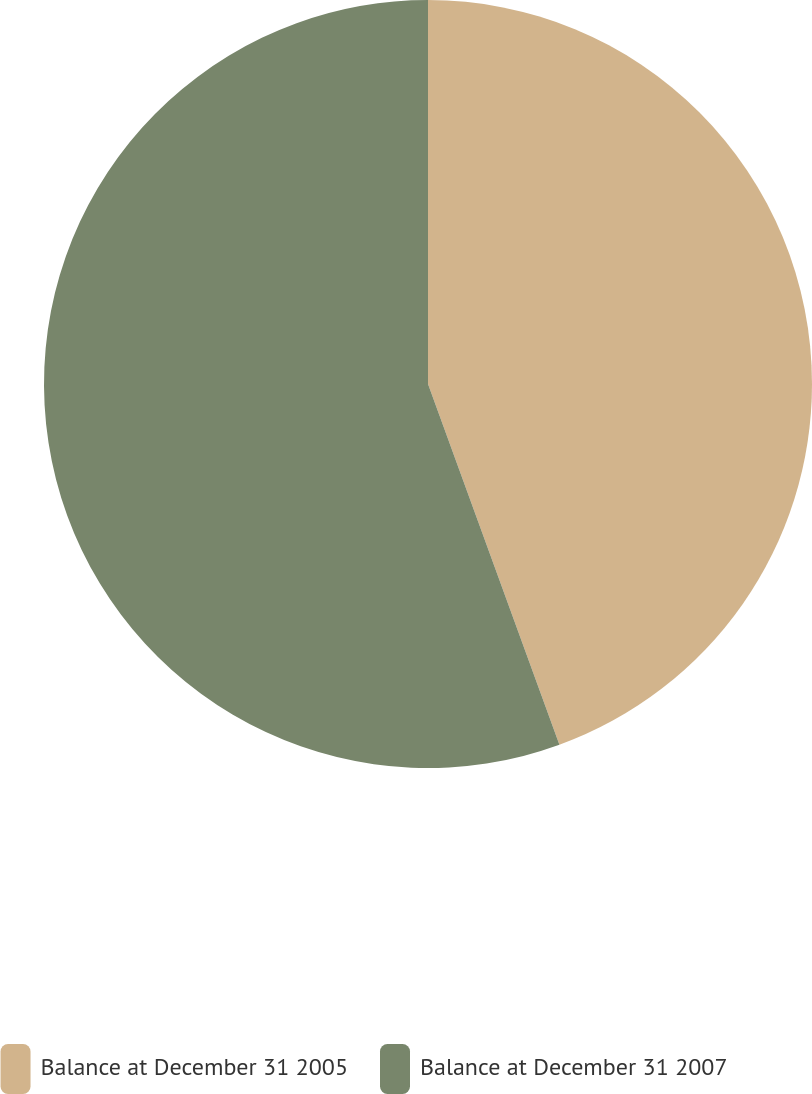<chart> <loc_0><loc_0><loc_500><loc_500><pie_chart><fcel>Balance at December 31 2005<fcel>Balance at December 31 2007<nl><fcel>44.44%<fcel>55.56%<nl></chart> 